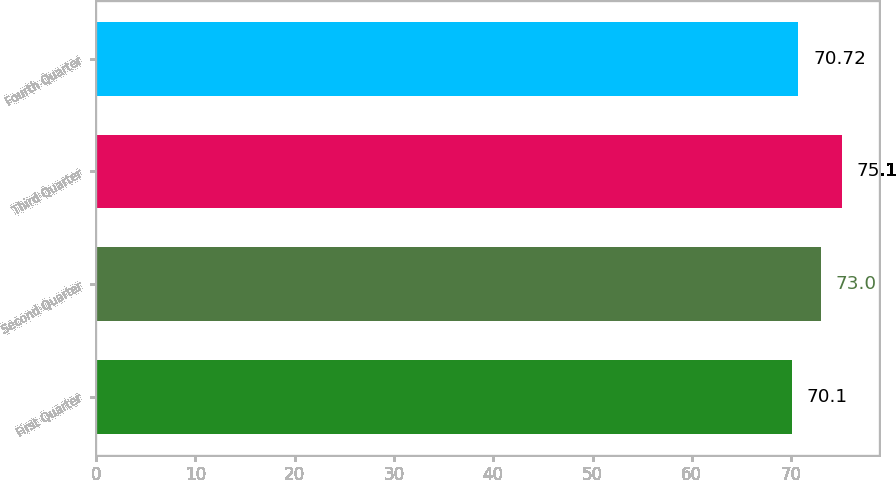Convert chart. <chart><loc_0><loc_0><loc_500><loc_500><bar_chart><fcel>First Quarter<fcel>Second Quarter<fcel>Third Quarter<fcel>Fourth Quarter<nl><fcel>70.1<fcel>73<fcel>75.1<fcel>70.72<nl></chart> 